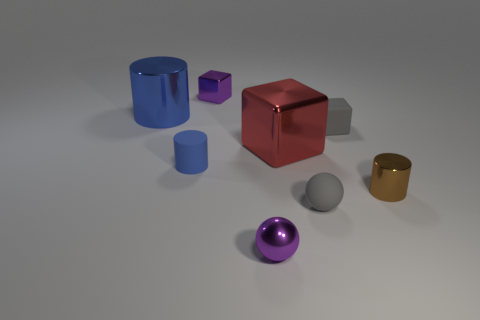Add 1 tiny brown cylinders. How many objects exist? 9 Subtract all cylinders. How many objects are left? 5 Add 5 purple shiny things. How many purple shiny things exist? 7 Subtract 0 yellow cubes. How many objects are left? 8 Subtract all red cubes. Subtract all large shiny blocks. How many objects are left? 6 Add 8 matte blocks. How many matte blocks are left? 9 